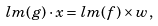<formula> <loc_0><loc_0><loc_500><loc_500>l m ( g ) \cdot x = l m ( f ) \times w ,</formula> 